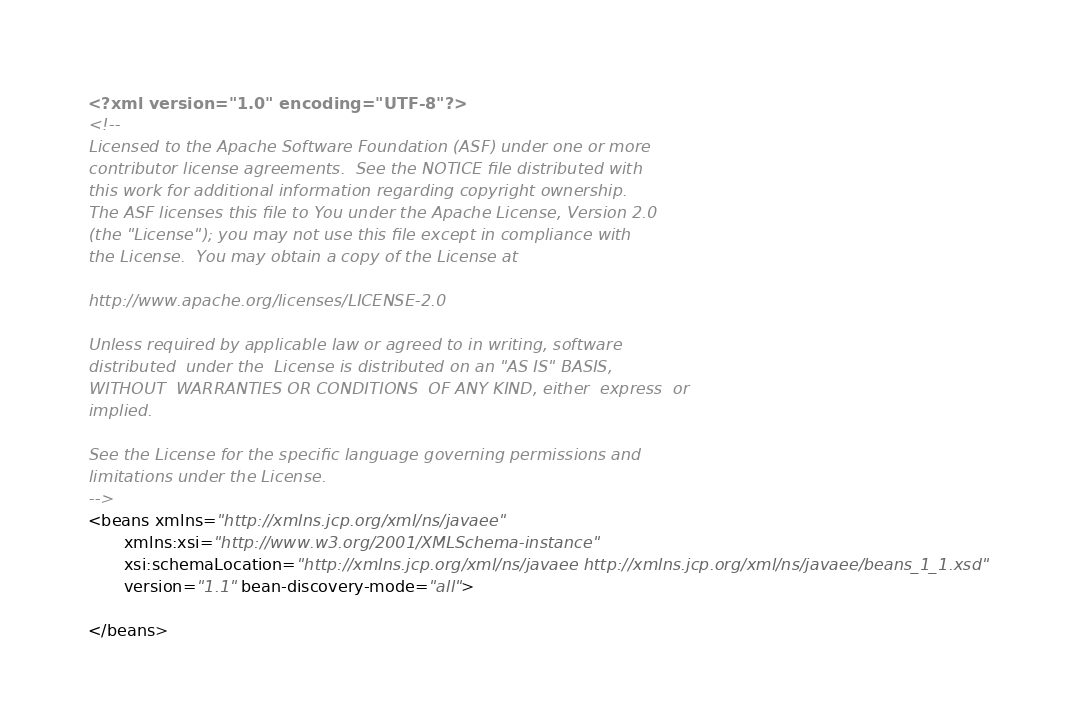<code> <loc_0><loc_0><loc_500><loc_500><_XML_><?xml version="1.0" encoding="UTF-8"?>
<!-- 
Licensed to the Apache Software Foundation (ASF) under one or more
contributor license agreements.  See the NOTICE file distributed with
this work for additional information regarding copyright ownership.
The ASF licenses this file to You under the Apache License, Version 2.0
(the "License"); you may not use this file except in compliance with
the License.  You may obtain a copy of the License at 

http://www.apache.org/licenses/LICENSE-2.0

Unless required by applicable law or agreed to in writing, software
distributed  under the  License is distributed on an "AS IS" BASIS,
WITHOUT  WARRANTIES OR CONDITIONS  OF ANY KIND, either  express  or
implied.

See the License for the specific language governing permissions and
limitations under the License.
-->
<beans xmlns="http://xmlns.jcp.org/xml/ns/javaee"
       xmlns:xsi="http://www.w3.org/2001/XMLSchema-instance"
       xsi:schemaLocation="http://xmlns.jcp.org/xml/ns/javaee http://xmlns.jcp.org/xml/ns/javaee/beans_1_1.xsd"
       version="1.1" bean-discovery-mode="all">
   
</beans></code> 